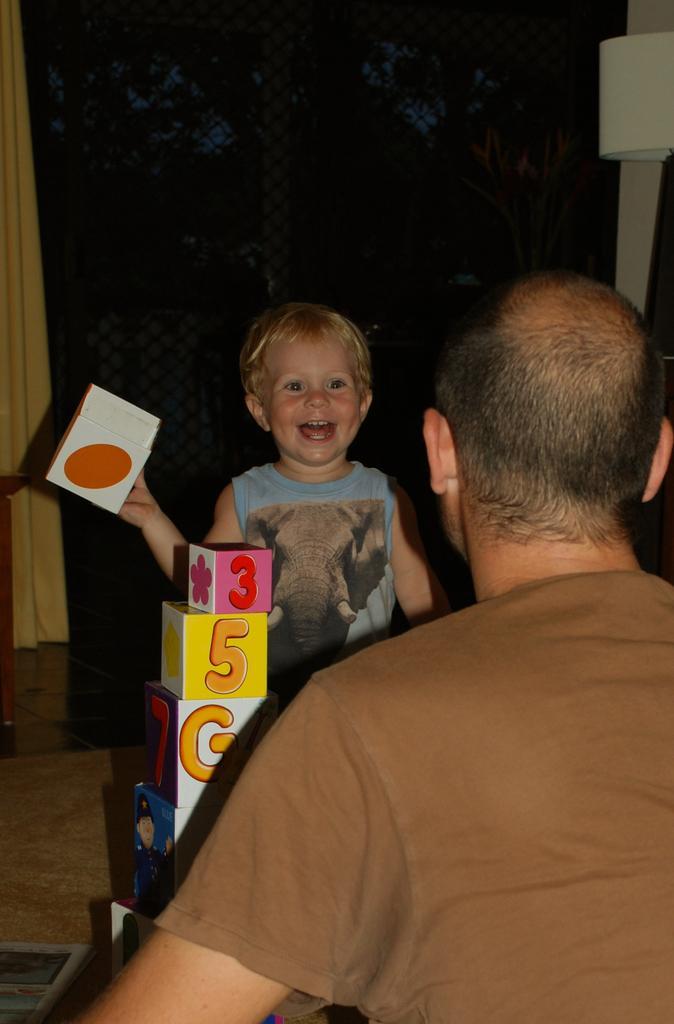Can you describe this image briefly? Here in this picture in the middle we can see a child standing over a place and smiling and in front of him we can see a person present and in the middle we can see some puzzle boxes present over there and we can see the child is holding one of the box in his hand over there and behind him we can see a curtain present over there and we can also see a lamp present over there. 